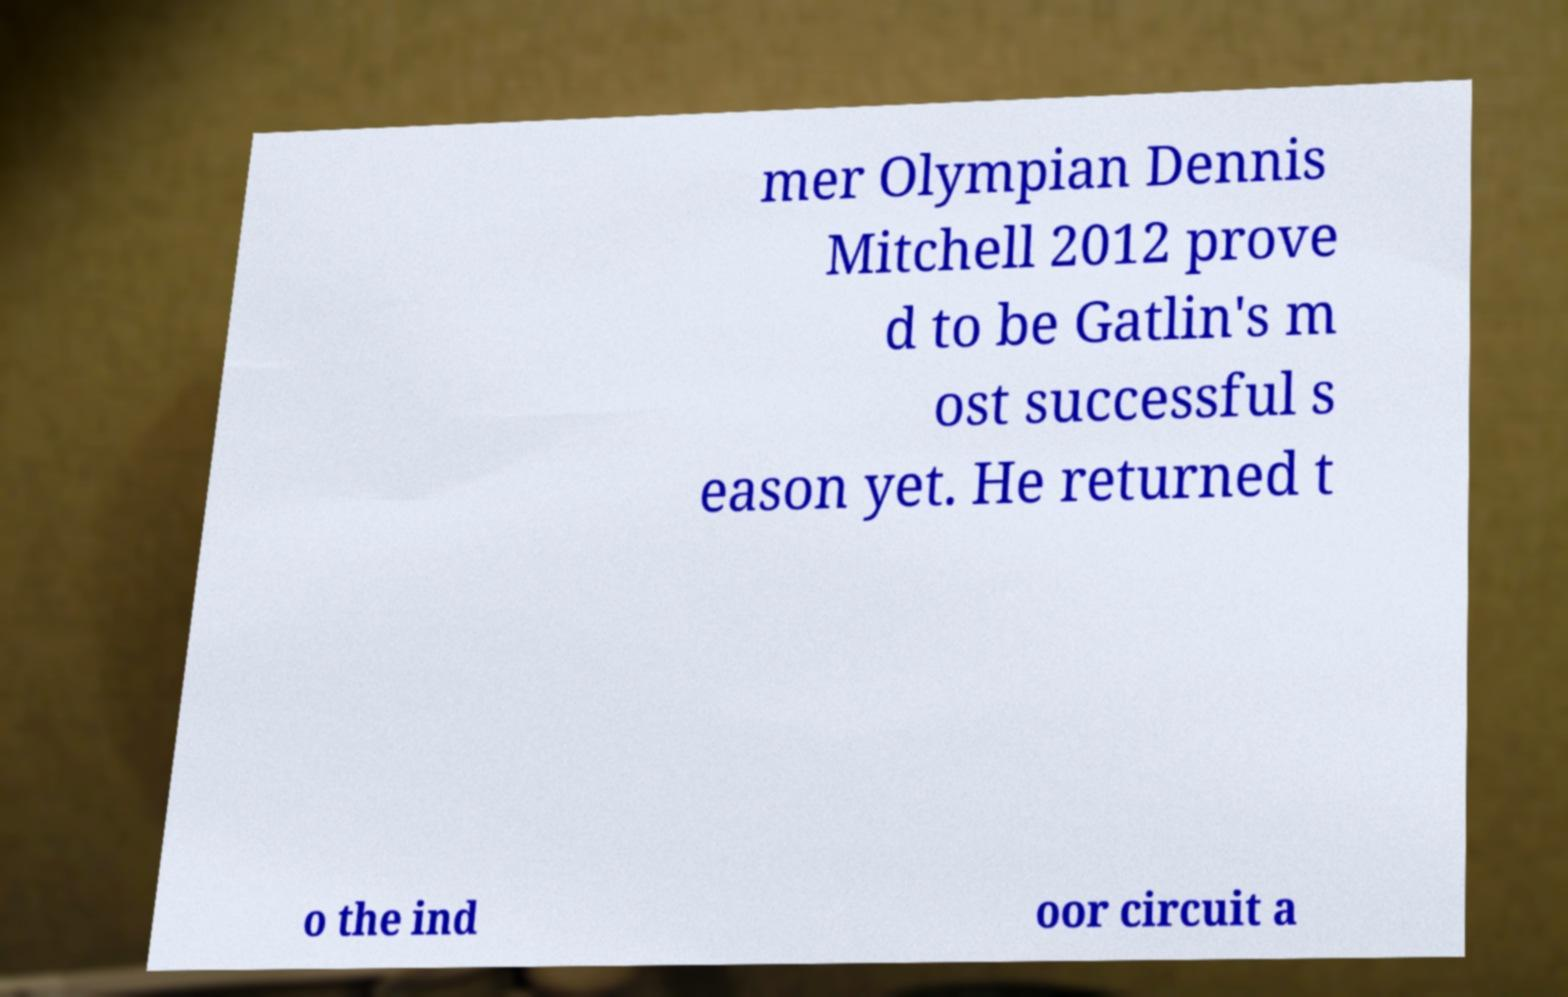There's text embedded in this image that I need extracted. Can you transcribe it verbatim? mer Olympian Dennis Mitchell 2012 prove d to be Gatlin's m ost successful s eason yet. He returned t o the ind oor circuit a 